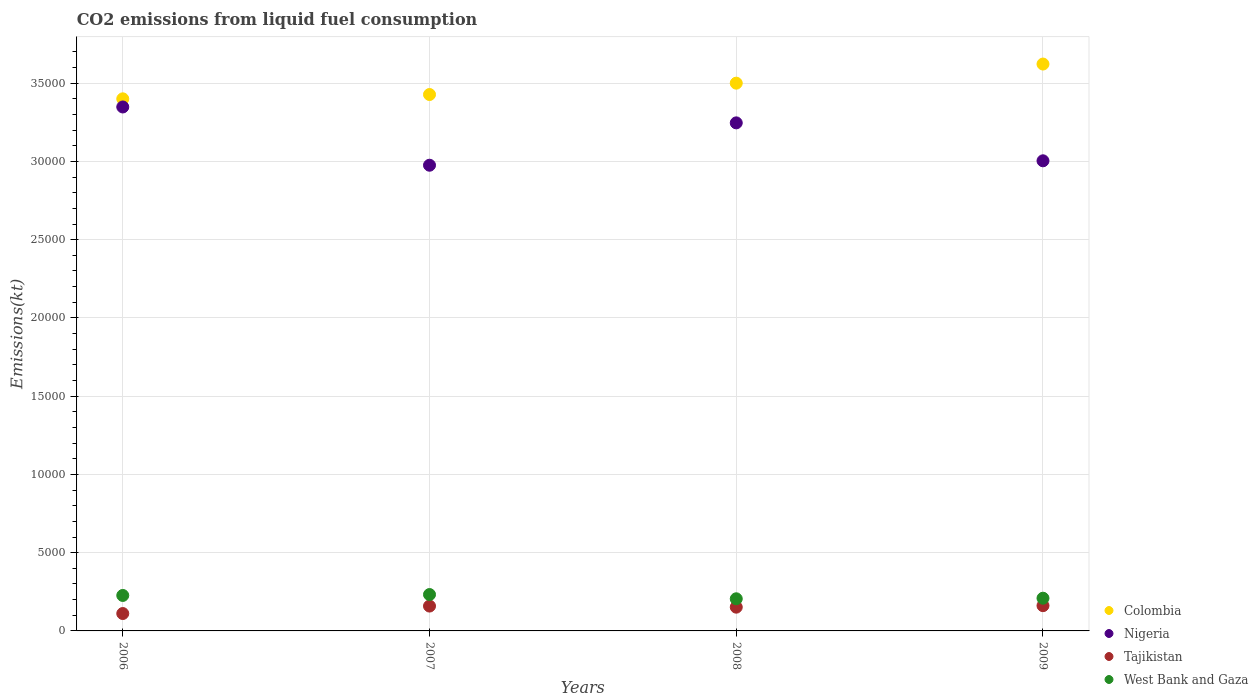How many different coloured dotlines are there?
Provide a short and direct response. 4. What is the amount of CO2 emitted in Tajikistan in 2008?
Give a very brief answer. 1518.14. Across all years, what is the maximum amount of CO2 emitted in Tajikistan?
Keep it short and to the point. 1613.48. Across all years, what is the minimum amount of CO2 emitted in West Bank and Gaza?
Offer a very short reply. 2053.52. What is the total amount of CO2 emitted in West Bank and Gaza in the graph?
Your answer should be very brief. 8734.79. What is the difference between the amount of CO2 emitted in Tajikistan in 2008 and that in 2009?
Provide a succinct answer. -95.34. What is the difference between the amount of CO2 emitted in Nigeria in 2006 and the amount of CO2 emitted in West Bank and Gaza in 2009?
Keep it short and to the point. 3.14e+04. What is the average amount of CO2 emitted in Nigeria per year?
Provide a short and direct response. 3.14e+04. In the year 2008, what is the difference between the amount of CO2 emitted in Nigeria and amount of CO2 emitted in Colombia?
Provide a short and direct response. -2537.56. What is the ratio of the amount of CO2 emitted in West Bank and Gaza in 2006 to that in 2008?
Offer a terse response. 1.1. Is the difference between the amount of CO2 emitted in Nigeria in 2007 and 2008 greater than the difference between the amount of CO2 emitted in Colombia in 2007 and 2008?
Ensure brevity in your answer.  No. What is the difference between the highest and the second highest amount of CO2 emitted in Nigeria?
Provide a succinct answer. 1015.76. What is the difference between the highest and the lowest amount of CO2 emitted in Nigeria?
Your response must be concise. 3722. Is it the case that in every year, the sum of the amount of CO2 emitted in West Bank and Gaza and amount of CO2 emitted in Nigeria  is greater than the amount of CO2 emitted in Tajikistan?
Your answer should be very brief. Yes. Is the amount of CO2 emitted in West Bank and Gaza strictly greater than the amount of CO2 emitted in Colombia over the years?
Offer a terse response. No. How many years are there in the graph?
Your response must be concise. 4. What is the difference between two consecutive major ticks on the Y-axis?
Your answer should be very brief. 5000. Does the graph contain grids?
Your response must be concise. Yes. What is the title of the graph?
Offer a terse response. CO2 emissions from liquid fuel consumption. Does "Thailand" appear as one of the legend labels in the graph?
Keep it short and to the point. No. What is the label or title of the X-axis?
Your answer should be very brief. Years. What is the label or title of the Y-axis?
Your answer should be compact. Emissions(kt). What is the Emissions(kt) of Colombia in 2006?
Offer a very short reply. 3.40e+04. What is the Emissions(kt) in Nigeria in 2006?
Provide a short and direct response. 3.35e+04. What is the Emissions(kt) of Tajikistan in 2006?
Offer a very short reply. 1111.1. What is the Emissions(kt) in West Bank and Gaza in 2006?
Provide a succinct answer. 2266.21. What is the Emissions(kt) in Colombia in 2007?
Offer a terse response. 3.43e+04. What is the Emissions(kt) in Nigeria in 2007?
Keep it short and to the point. 2.98e+04. What is the Emissions(kt) in Tajikistan in 2007?
Provide a short and direct response. 1587.81. What is the Emissions(kt) in West Bank and Gaza in 2007?
Offer a terse response. 2324.88. What is the Emissions(kt) in Colombia in 2008?
Provide a short and direct response. 3.50e+04. What is the Emissions(kt) in Nigeria in 2008?
Provide a short and direct response. 3.25e+04. What is the Emissions(kt) of Tajikistan in 2008?
Give a very brief answer. 1518.14. What is the Emissions(kt) of West Bank and Gaza in 2008?
Provide a short and direct response. 2053.52. What is the Emissions(kt) of Colombia in 2009?
Your answer should be very brief. 3.62e+04. What is the Emissions(kt) in Nigeria in 2009?
Provide a short and direct response. 3.00e+04. What is the Emissions(kt) in Tajikistan in 2009?
Provide a short and direct response. 1613.48. What is the Emissions(kt) of West Bank and Gaza in 2009?
Offer a very short reply. 2090.19. Across all years, what is the maximum Emissions(kt) in Colombia?
Your answer should be very brief. 3.62e+04. Across all years, what is the maximum Emissions(kt) in Nigeria?
Keep it short and to the point. 3.35e+04. Across all years, what is the maximum Emissions(kt) in Tajikistan?
Give a very brief answer. 1613.48. Across all years, what is the maximum Emissions(kt) in West Bank and Gaza?
Ensure brevity in your answer.  2324.88. Across all years, what is the minimum Emissions(kt) in Colombia?
Keep it short and to the point. 3.40e+04. Across all years, what is the minimum Emissions(kt) of Nigeria?
Your answer should be compact. 2.98e+04. Across all years, what is the minimum Emissions(kt) of Tajikistan?
Provide a short and direct response. 1111.1. Across all years, what is the minimum Emissions(kt) of West Bank and Gaza?
Your response must be concise. 2053.52. What is the total Emissions(kt) of Colombia in the graph?
Your response must be concise. 1.40e+05. What is the total Emissions(kt) of Nigeria in the graph?
Make the answer very short. 1.26e+05. What is the total Emissions(kt) of Tajikistan in the graph?
Provide a short and direct response. 5830.53. What is the total Emissions(kt) of West Bank and Gaza in the graph?
Offer a terse response. 8734.79. What is the difference between the Emissions(kt) in Colombia in 2006 and that in 2007?
Offer a terse response. -275.02. What is the difference between the Emissions(kt) in Nigeria in 2006 and that in 2007?
Provide a succinct answer. 3722.01. What is the difference between the Emissions(kt) in Tajikistan in 2006 and that in 2007?
Provide a succinct answer. -476.71. What is the difference between the Emissions(kt) of West Bank and Gaza in 2006 and that in 2007?
Ensure brevity in your answer.  -58.67. What is the difference between the Emissions(kt) in Colombia in 2006 and that in 2008?
Provide a short and direct response. -1001.09. What is the difference between the Emissions(kt) in Nigeria in 2006 and that in 2008?
Make the answer very short. 1015.76. What is the difference between the Emissions(kt) in Tajikistan in 2006 and that in 2008?
Offer a terse response. -407.04. What is the difference between the Emissions(kt) of West Bank and Gaza in 2006 and that in 2008?
Your answer should be very brief. 212.69. What is the difference between the Emissions(kt) in Colombia in 2006 and that in 2009?
Make the answer very short. -2222.2. What is the difference between the Emissions(kt) of Nigeria in 2006 and that in 2009?
Offer a terse response. 3439.65. What is the difference between the Emissions(kt) in Tajikistan in 2006 and that in 2009?
Your answer should be compact. -502.38. What is the difference between the Emissions(kt) in West Bank and Gaza in 2006 and that in 2009?
Ensure brevity in your answer.  176.02. What is the difference between the Emissions(kt) in Colombia in 2007 and that in 2008?
Your response must be concise. -726.07. What is the difference between the Emissions(kt) in Nigeria in 2007 and that in 2008?
Make the answer very short. -2706.25. What is the difference between the Emissions(kt) of Tajikistan in 2007 and that in 2008?
Your response must be concise. 69.67. What is the difference between the Emissions(kt) of West Bank and Gaza in 2007 and that in 2008?
Your response must be concise. 271.36. What is the difference between the Emissions(kt) of Colombia in 2007 and that in 2009?
Provide a short and direct response. -1947.18. What is the difference between the Emissions(kt) of Nigeria in 2007 and that in 2009?
Give a very brief answer. -282.36. What is the difference between the Emissions(kt) of Tajikistan in 2007 and that in 2009?
Keep it short and to the point. -25.67. What is the difference between the Emissions(kt) in West Bank and Gaza in 2007 and that in 2009?
Offer a very short reply. 234.69. What is the difference between the Emissions(kt) of Colombia in 2008 and that in 2009?
Offer a very short reply. -1221.11. What is the difference between the Emissions(kt) of Nigeria in 2008 and that in 2009?
Offer a terse response. 2423.89. What is the difference between the Emissions(kt) of Tajikistan in 2008 and that in 2009?
Provide a short and direct response. -95.34. What is the difference between the Emissions(kt) of West Bank and Gaza in 2008 and that in 2009?
Your response must be concise. -36.67. What is the difference between the Emissions(kt) in Colombia in 2006 and the Emissions(kt) in Nigeria in 2007?
Your response must be concise. 4242.72. What is the difference between the Emissions(kt) of Colombia in 2006 and the Emissions(kt) of Tajikistan in 2007?
Your answer should be compact. 3.24e+04. What is the difference between the Emissions(kt) of Colombia in 2006 and the Emissions(kt) of West Bank and Gaza in 2007?
Offer a terse response. 3.17e+04. What is the difference between the Emissions(kt) of Nigeria in 2006 and the Emissions(kt) of Tajikistan in 2007?
Make the answer very short. 3.19e+04. What is the difference between the Emissions(kt) in Nigeria in 2006 and the Emissions(kt) in West Bank and Gaza in 2007?
Your response must be concise. 3.12e+04. What is the difference between the Emissions(kt) of Tajikistan in 2006 and the Emissions(kt) of West Bank and Gaza in 2007?
Offer a terse response. -1213.78. What is the difference between the Emissions(kt) in Colombia in 2006 and the Emissions(kt) in Nigeria in 2008?
Make the answer very short. 1536.47. What is the difference between the Emissions(kt) in Colombia in 2006 and the Emissions(kt) in Tajikistan in 2008?
Offer a terse response. 3.25e+04. What is the difference between the Emissions(kt) of Colombia in 2006 and the Emissions(kt) of West Bank and Gaza in 2008?
Provide a short and direct response. 3.19e+04. What is the difference between the Emissions(kt) in Nigeria in 2006 and the Emissions(kt) in Tajikistan in 2008?
Keep it short and to the point. 3.20e+04. What is the difference between the Emissions(kt) of Nigeria in 2006 and the Emissions(kt) of West Bank and Gaza in 2008?
Your answer should be compact. 3.14e+04. What is the difference between the Emissions(kt) of Tajikistan in 2006 and the Emissions(kt) of West Bank and Gaza in 2008?
Your answer should be very brief. -942.42. What is the difference between the Emissions(kt) of Colombia in 2006 and the Emissions(kt) of Nigeria in 2009?
Keep it short and to the point. 3960.36. What is the difference between the Emissions(kt) of Colombia in 2006 and the Emissions(kt) of Tajikistan in 2009?
Offer a terse response. 3.24e+04. What is the difference between the Emissions(kt) in Colombia in 2006 and the Emissions(kt) in West Bank and Gaza in 2009?
Make the answer very short. 3.19e+04. What is the difference between the Emissions(kt) of Nigeria in 2006 and the Emissions(kt) of Tajikistan in 2009?
Offer a terse response. 3.19e+04. What is the difference between the Emissions(kt) of Nigeria in 2006 and the Emissions(kt) of West Bank and Gaza in 2009?
Offer a terse response. 3.14e+04. What is the difference between the Emissions(kt) in Tajikistan in 2006 and the Emissions(kt) in West Bank and Gaza in 2009?
Offer a terse response. -979.09. What is the difference between the Emissions(kt) of Colombia in 2007 and the Emissions(kt) of Nigeria in 2008?
Ensure brevity in your answer.  1811.5. What is the difference between the Emissions(kt) in Colombia in 2007 and the Emissions(kt) in Tajikistan in 2008?
Provide a succinct answer. 3.28e+04. What is the difference between the Emissions(kt) in Colombia in 2007 and the Emissions(kt) in West Bank and Gaza in 2008?
Ensure brevity in your answer.  3.22e+04. What is the difference between the Emissions(kt) in Nigeria in 2007 and the Emissions(kt) in Tajikistan in 2008?
Make the answer very short. 2.82e+04. What is the difference between the Emissions(kt) in Nigeria in 2007 and the Emissions(kt) in West Bank and Gaza in 2008?
Your response must be concise. 2.77e+04. What is the difference between the Emissions(kt) of Tajikistan in 2007 and the Emissions(kt) of West Bank and Gaza in 2008?
Your response must be concise. -465.71. What is the difference between the Emissions(kt) in Colombia in 2007 and the Emissions(kt) in Nigeria in 2009?
Keep it short and to the point. 4235.39. What is the difference between the Emissions(kt) of Colombia in 2007 and the Emissions(kt) of Tajikistan in 2009?
Ensure brevity in your answer.  3.27e+04. What is the difference between the Emissions(kt) of Colombia in 2007 and the Emissions(kt) of West Bank and Gaza in 2009?
Provide a short and direct response. 3.22e+04. What is the difference between the Emissions(kt) of Nigeria in 2007 and the Emissions(kt) of Tajikistan in 2009?
Your answer should be very brief. 2.81e+04. What is the difference between the Emissions(kt) of Nigeria in 2007 and the Emissions(kt) of West Bank and Gaza in 2009?
Your response must be concise. 2.77e+04. What is the difference between the Emissions(kt) of Tajikistan in 2007 and the Emissions(kt) of West Bank and Gaza in 2009?
Provide a short and direct response. -502.38. What is the difference between the Emissions(kt) in Colombia in 2008 and the Emissions(kt) in Nigeria in 2009?
Give a very brief answer. 4961.45. What is the difference between the Emissions(kt) in Colombia in 2008 and the Emissions(kt) in Tajikistan in 2009?
Ensure brevity in your answer.  3.34e+04. What is the difference between the Emissions(kt) of Colombia in 2008 and the Emissions(kt) of West Bank and Gaza in 2009?
Make the answer very short. 3.29e+04. What is the difference between the Emissions(kt) of Nigeria in 2008 and the Emissions(kt) of Tajikistan in 2009?
Offer a very short reply. 3.09e+04. What is the difference between the Emissions(kt) in Nigeria in 2008 and the Emissions(kt) in West Bank and Gaza in 2009?
Your answer should be very brief. 3.04e+04. What is the difference between the Emissions(kt) of Tajikistan in 2008 and the Emissions(kt) of West Bank and Gaza in 2009?
Your response must be concise. -572.05. What is the average Emissions(kt) of Colombia per year?
Your answer should be very brief. 3.49e+04. What is the average Emissions(kt) in Nigeria per year?
Your answer should be compact. 3.14e+04. What is the average Emissions(kt) of Tajikistan per year?
Provide a succinct answer. 1457.63. What is the average Emissions(kt) in West Bank and Gaza per year?
Ensure brevity in your answer.  2183.7. In the year 2006, what is the difference between the Emissions(kt) in Colombia and Emissions(kt) in Nigeria?
Make the answer very short. 520.71. In the year 2006, what is the difference between the Emissions(kt) of Colombia and Emissions(kt) of Tajikistan?
Your answer should be compact. 3.29e+04. In the year 2006, what is the difference between the Emissions(kt) in Colombia and Emissions(kt) in West Bank and Gaza?
Provide a short and direct response. 3.17e+04. In the year 2006, what is the difference between the Emissions(kt) in Nigeria and Emissions(kt) in Tajikistan?
Provide a succinct answer. 3.24e+04. In the year 2006, what is the difference between the Emissions(kt) in Nigeria and Emissions(kt) in West Bank and Gaza?
Offer a very short reply. 3.12e+04. In the year 2006, what is the difference between the Emissions(kt) of Tajikistan and Emissions(kt) of West Bank and Gaza?
Your answer should be compact. -1155.11. In the year 2007, what is the difference between the Emissions(kt) in Colombia and Emissions(kt) in Nigeria?
Provide a succinct answer. 4517.74. In the year 2007, what is the difference between the Emissions(kt) of Colombia and Emissions(kt) of Tajikistan?
Your answer should be compact. 3.27e+04. In the year 2007, what is the difference between the Emissions(kt) of Colombia and Emissions(kt) of West Bank and Gaza?
Make the answer very short. 3.20e+04. In the year 2007, what is the difference between the Emissions(kt) of Nigeria and Emissions(kt) of Tajikistan?
Your response must be concise. 2.82e+04. In the year 2007, what is the difference between the Emissions(kt) in Nigeria and Emissions(kt) in West Bank and Gaza?
Provide a short and direct response. 2.74e+04. In the year 2007, what is the difference between the Emissions(kt) of Tajikistan and Emissions(kt) of West Bank and Gaza?
Your response must be concise. -737.07. In the year 2008, what is the difference between the Emissions(kt) of Colombia and Emissions(kt) of Nigeria?
Offer a very short reply. 2537.56. In the year 2008, what is the difference between the Emissions(kt) in Colombia and Emissions(kt) in Tajikistan?
Ensure brevity in your answer.  3.35e+04. In the year 2008, what is the difference between the Emissions(kt) of Colombia and Emissions(kt) of West Bank and Gaza?
Provide a succinct answer. 3.29e+04. In the year 2008, what is the difference between the Emissions(kt) of Nigeria and Emissions(kt) of Tajikistan?
Offer a terse response. 3.09e+04. In the year 2008, what is the difference between the Emissions(kt) of Nigeria and Emissions(kt) of West Bank and Gaza?
Give a very brief answer. 3.04e+04. In the year 2008, what is the difference between the Emissions(kt) in Tajikistan and Emissions(kt) in West Bank and Gaza?
Keep it short and to the point. -535.38. In the year 2009, what is the difference between the Emissions(kt) in Colombia and Emissions(kt) in Nigeria?
Give a very brief answer. 6182.56. In the year 2009, what is the difference between the Emissions(kt) in Colombia and Emissions(kt) in Tajikistan?
Ensure brevity in your answer.  3.46e+04. In the year 2009, what is the difference between the Emissions(kt) of Colombia and Emissions(kt) of West Bank and Gaza?
Provide a short and direct response. 3.41e+04. In the year 2009, what is the difference between the Emissions(kt) of Nigeria and Emissions(kt) of Tajikistan?
Give a very brief answer. 2.84e+04. In the year 2009, what is the difference between the Emissions(kt) of Nigeria and Emissions(kt) of West Bank and Gaza?
Ensure brevity in your answer.  2.79e+04. In the year 2009, what is the difference between the Emissions(kt) of Tajikistan and Emissions(kt) of West Bank and Gaza?
Offer a terse response. -476.71. What is the ratio of the Emissions(kt) of Nigeria in 2006 to that in 2007?
Your answer should be very brief. 1.13. What is the ratio of the Emissions(kt) in Tajikistan in 2006 to that in 2007?
Offer a very short reply. 0.7. What is the ratio of the Emissions(kt) in West Bank and Gaza in 2006 to that in 2007?
Your answer should be compact. 0.97. What is the ratio of the Emissions(kt) of Colombia in 2006 to that in 2008?
Make the answer very short. 0.97. What is the ratio of the Emissions(kt) of Nigeria in 2006 to that in 2008?
Provide a succinct answer. 1.03. What is the ratio of the Emissions(kt) of Tajikistan in 2006 to that in 2008?
Your response must be concise. 0.73. What is the ratio of the Emissions(kt) in West Bank and Gaza in 2006 to that in 2008?
Offer a terse response. 1.1. What is the ratio of the Emissions(kt) of Colombia in 2006 to that in 2009?
Keep it short and to the point. 0.94. What is the ratio of the Emissions(kt) of Nigeria in 2006 to that in 2009?
Give a very brief answer. 1.11. What is the ratio of the Emissions(kt) in Tajikistan in 2006 to that in 2009?
Provide a short and direct response. 0.69. What is the ratio of the Emissions(kt) in West Bank and Gaza in 2006 to that in 2009?
Your answer should be very brief. 1.08. What is the ratio of the Emissions(kt) in Colombia in 2007 to that in 2008?
Your answer should be very brief. 0.98. What is the ratio of the Emissions(kt) of Nigeria in 2007 to that in 2008?
Your response must be concise. 0.92. What is the ratio of the Emissions(kt) of Tajikistan in 2007 to that in 2008?
Offer a very short reply. 1.05. What is the ratio of the Emissions(kt) in West Bank and Gaza in 2007 to that in 2008?
Your answer should be compact. 1.13. What is the ratio of the Emissions(kt) of Colombia in 2007 to that in 2009?
Your response must be concise. 0.95. What is the ratio of the Emissions(kt) of Nigeria in 2007 to that in 2009?
Give a very brief answer. 0.99. What is the ratio of the Emissions(kt) in Tajikistan in 2007 to that in 2009?
Make the answer very short. 0.98. What is the ratio of the Emissions(kt) in West Bank and Gaza in 2007 to that in 2009?
Your response must be concise. 1.11. What is the ratio of the Emissions(kt) in Colombia in 2008 to that in 2009?
Offer a terse response. 0.97. What is the ratio of the Emissions(kt) in Nigeria in 2008 to that in 2009?
Offer a very short reply. 1.08. What is the ratio of the Emissions(kt) in Tajikistan in 2008 to that in 2009?
Give a very brief answer. 0.94. What is the ratio of the Emissions(kt) in West Bank and Gaza in 2008 to that in 2009?
Ensure brevity in your answer.  0.98. What is the difference between the highest and the second highest Emissions(kt) of Colombia?
Your answer should be very brief. 1221.11. What is the difference between the highest and the second highest Emissions(kt) in Nigeria?
Make the answer very short. 1015.76. What is the difference between the highest and the second highest Emissions(kt) of Tajikistan?
Your response must be concise. 25.67. What is the difference between the highest and the second highest Emissions(kt) of West Bank and Gaza?
Your answer should be very brief. 58.67. What is the difference between the highest and the lowest Emissions(kt) of Colombia?
Give a very brief answer. 2222.2. What is the difference between the highest and the lowest Emissions(kt) in Nigeria?
Ensure brevity in your answer.  3722.01. What is the difference between the highest and the lowest Emissions(kt) in Tajikistan?
Make the answer very short. 502.38. What is the difference between the highest and the lowest Emissions(kt) in West Bank and Gaza?
Your answer should be very brief. 271.36. 